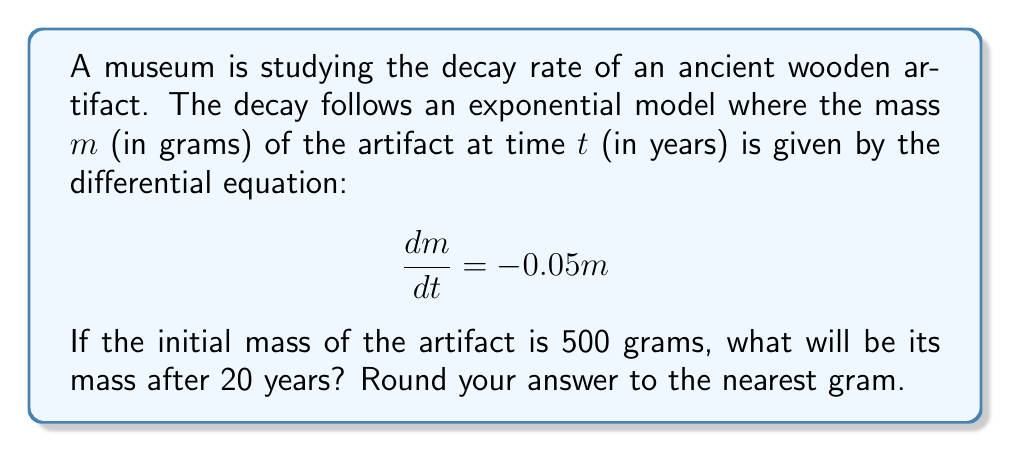Give your solution to this math problem. To solve this problem, we'll follow these steps:

1) The given differential equation is:

   $$\frac{dm}{dt} = -0.05m$$

   This is a separable first-order differential equation.

2) We can solve this by separating variables:

   $$\frac{dm}{m} = -0.05dt$$

3) Integrating both sides:

   $$\int \frac{dm}{m} = \int -0.05dt$$
   
   $$\ln|m| = -0.05t + C$$

4) We can rewrite this as:

   $$m = Ae^{-0.05t}$$

   where $A$ is a constant we'll determine from the initial condition.

5) We're given that the initial mass (at $t=0$) is 500 grams. Let's use this:

   $$500 = Ae^{-0.05(0)} = A$$

6) So our specific solution is:

   $$m = 500e^{-0.05t}$$

7) To find the mass after 20 years, we substitute $t=20$:

   $$m = 500e^{-0.05(20)} = 500e^{-1} \approx 183.9$$

8) Rounding to the nearest gram gives us 184 grams.

This exponential decay model is perfect for visualizing how artifacts deteriorate over time, which could be an engaging way to introduce mathematical concepts to an autistic child interested in history or museums.
Answer: 184 grams 